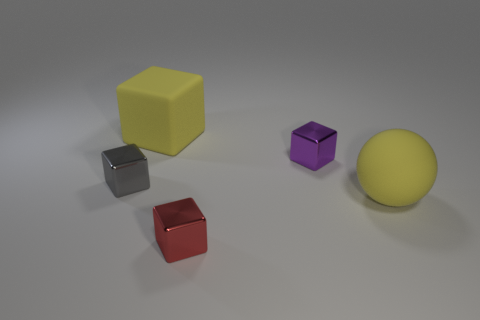Add 1 big yellow matte cubes. How many objects exist? 6 Subtract all spheres. How many objects are left? 4 Add 5 yellow matte blocks. How many yellow matte blocks are left? 6 Add 2 matte blocks. How many matte blocks exist? 3 Subtract 0 blue balls. How many objects are left? 5 Subtract all tiny gray cubes. Subtract all tiny cyan cubes. How many objects are left? 4 